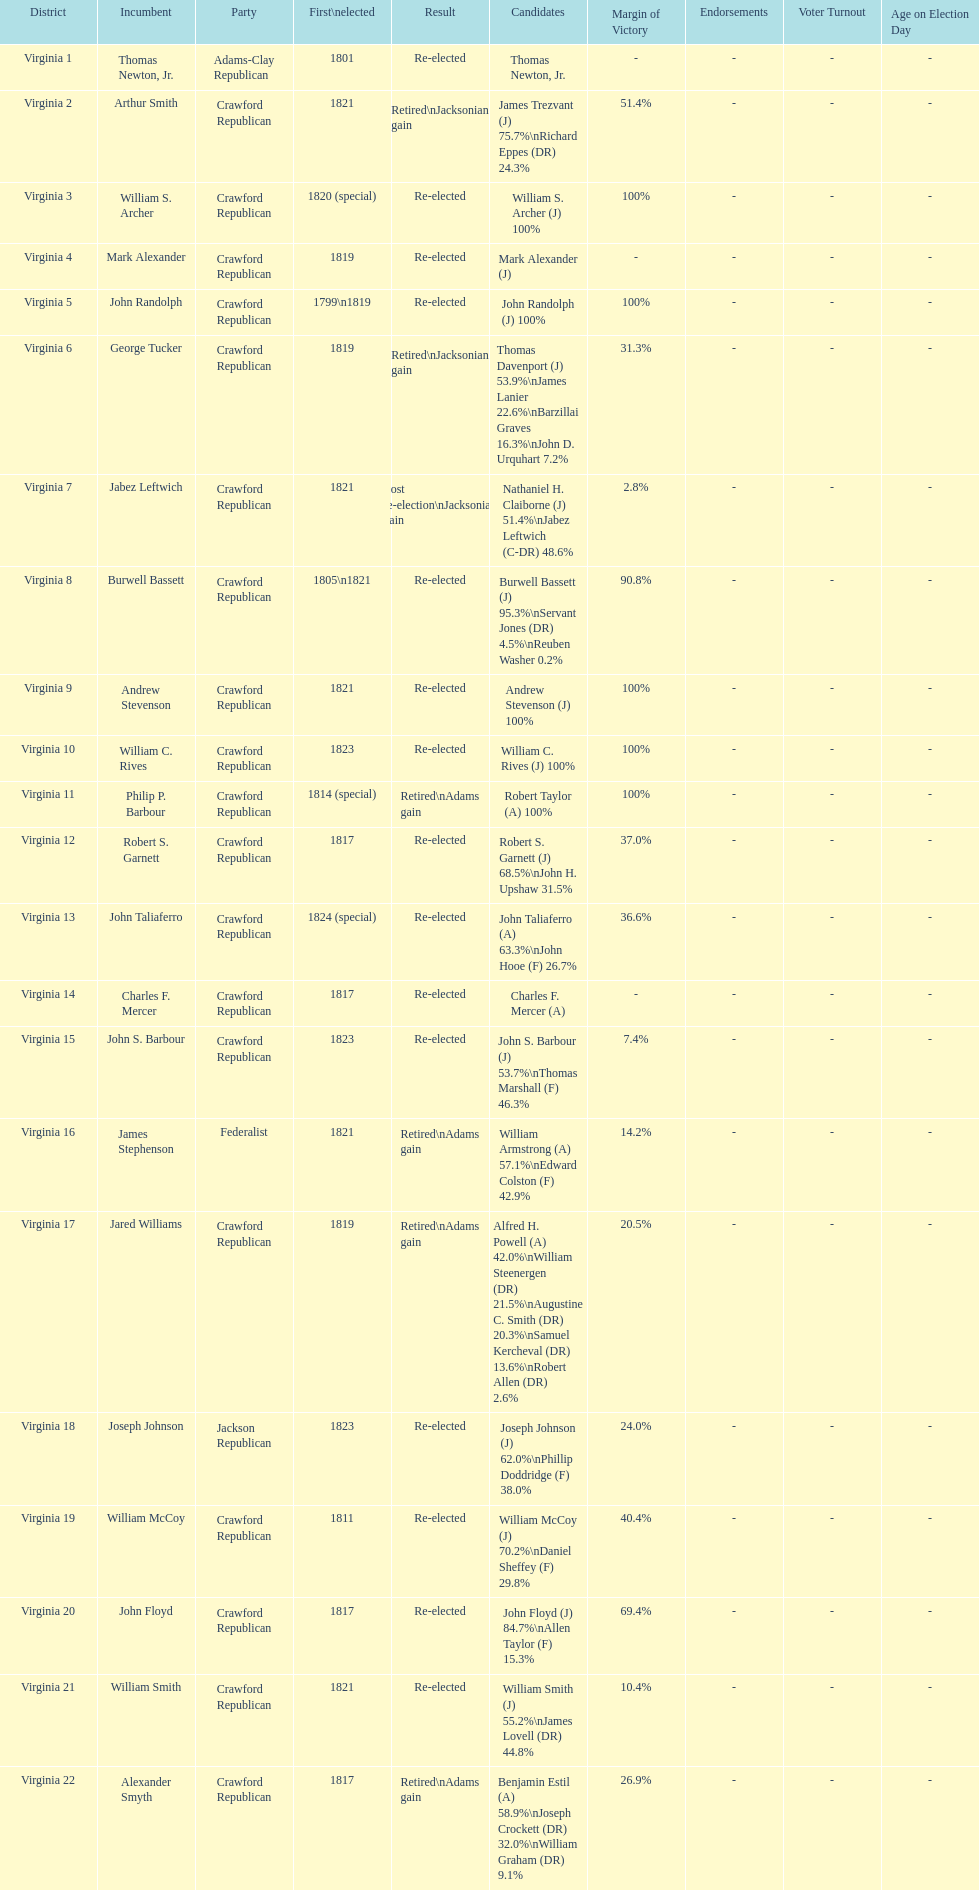Which jacksonian candidates got at least 76% of the vote in their races? Arthur Smith. 